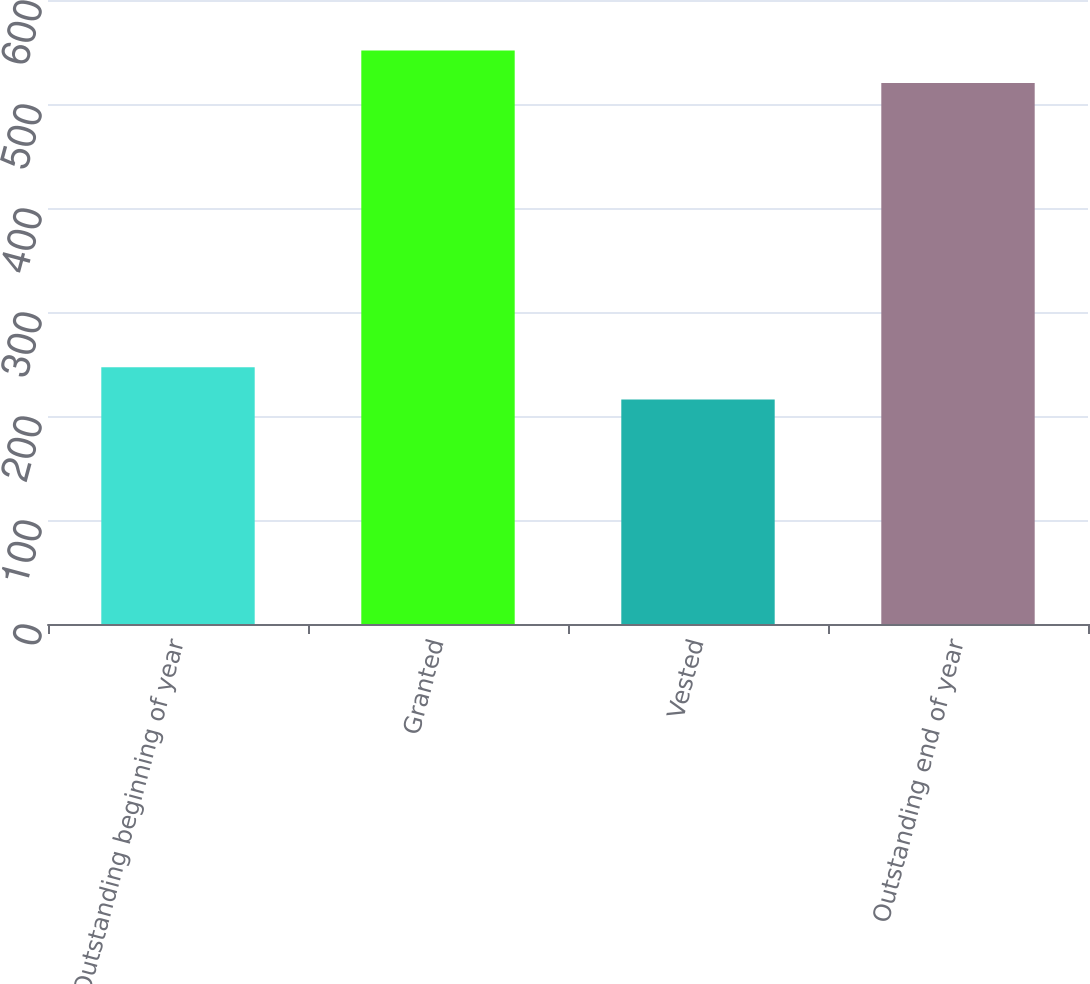<chart> <loc_0><loc_0><loc_500><loc_500><bar_chart><fcel>Outstanding beginning of year<fcel>Granted<fcel>Vested<fcel>Outstanding end of year<nl><fcel>246.93<fcel>551.44<fcel>215.76<fcel>520.27<nl></chart> 